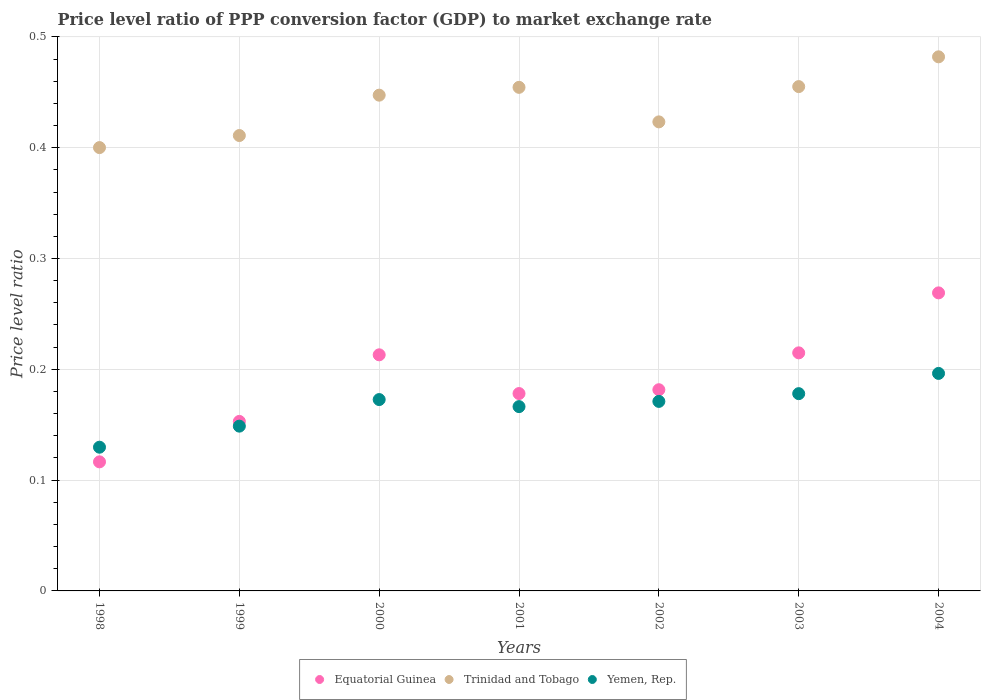How many different coloured dotlines are there?
Offer a terse response. 3. Is the number of dotlines equal to the number of legend labels?
Offer a terse response. Yes. What is the price level ratio in Yemen, Rep. in 2001?
Ensure brevity in your answer.  0.17. Across all years, what is the maximum price level ratio in Trinidad and Tobago?
Make the answer very short. 0.48. Across all years, what is the minimum price level ratio in Equatorial Guinea?
Ensure brevity in your answer.  0.12. What is the total price level ratio in Equatorial Guinea in the graph?
Ensure brevity in your answer.  1.33. What is the difference between the price level ratio in Equatorial Guinea in 2000 and that in 2001?
Your answer should be compact. 0.03. What is the difference between the price level ratio in Yemen, Rep. in 2003 and the price level ratio in Equatorial Guinea in 2000?
Make the answer very short. -0.04. What is the average price level ratio in Equatorial Guinea per year?
Offer a terse response. 0.19. In the year 2000, what is the difference between the price level ratio in Equatorial Guinea and price level ratio in Yemen, Rep.?
Your response must be concise. 0.04. What is the ratio of the price level ratio in Yemen, Rep. in 1999 to that in 2002?
Your answer should be compact. 0.87. Is the price level ratio in Yemen, Rep. in 2002 less than that in 2004?
Make the answer very short. Yes. What is the difference between the highest and the second highest price level ratio in Equatorial Guinea?
Offer a very short reply. 0.05. What is the difference between the highest and the lowest price level ratio in Yemen, Rep.?
Provide a short and direct response. 0.07. Is the sum of the price level ratio in Yemen, Rep. in 2002 and 2003 greater than the maximum price level ratio in Equatorial Guinea across all years?
Offer a terse response. Yes. Is it the case that in every year, the sum of the price level ratio in Equatorial Guinea and price level ratio in Trinidad and Tobago  is greater than the price level ratio in Yemen, Rep.?
Your response must be concise. Yes. Does the price level ratio in Trinidad and Tobago monotonically increase over the years?
Your answer should be very brief. No. Is the price level ratio in Trinidad and Tobago strictly less than the price level ratio in Equatorial Guinea over the years?
Provide a short and direct response. No. How many dotlines are there?
Give a very brief answer. 3. What is the difference between two consecutive major ticks on the Y-axis?
Keep it short and to the point. 0.1. Does the graph contain grids?
Keep it short and to the point. Yes. Where does the legend appear in the graph?
Provide a succinct answer. Bottom center. How many legend labels are there?
Offer a terse response. 3. How are the legend labels stacked?
Give a very brief answer. Horizontal. What is the title of the graph?
Offer a very short reply. Price level ratio of PPP conversion factor (GDP) to market exchange rate. What is the label or title of the Y-axis?
Give a very brief answer. Price level ratio. What is the Price level ratio of Equatorial Guinea in 1998?
Provide a succinct answer. 0.12. What is the Price level ratio of Trinidad and Tobago in 1998?
Offer a very short reply. 0.4. What is the Price level ratio in Yemen, Rep. in 1998?
Make the answer very short. 0.13. What is the Price level ratio in Equatorial Guinea in 1999?
Your answer should be compact. 0.15. What is the Price level ratio of Trinidad and Tobago in 1999?
Offer a terse response. 0.41. What is the Price level ratio in Yemen, Rep. in 1999?
Ensure brevity in your answer.  0.15. What is the Price level ratio in Equatorial Guinea in 2000?
Ensure brevity in your answer.  0.21. What is the Price level ratio in Trinidad and Tobago in 2000?
Your answer should be compact. 0.45. What is the Price level ratio of Yemen, Rep. in 2000?
Ensure brevity in your answer.  0.17. What is the Price level ratio of Equatorial Guinea in 2001?
Give a very brief answer. 0.18. What is the Price level ratio in Trinidad and Tobago in 2001?
Offer a terse response. 0.45. What is the Price level ratio of Yemen, Rep. in 2001?
Give a very brief answer. 0.17. What is the Price level ratio in Equatorial Guinea in 2002?
Keep it short and to the point. 0.18. What is the Price level ratio of Trinidad and Tobago in 2002?
Make the answer very short. 0.42. What is the Price level ratio in Yemen, Rep. in 2002?
Your answer should be compact. 0.17. What is the Price level ratio in Equatorial Guinea in 2003?
Offer a very short reply. 0.21. What is the Price level ratio of Trinidad and Tobago in 2003?
Make the answer very short. 0.46. What is the Price level ratio in Yemen, Rep. in 2003?
Make the answer very short. 0.18. What is the Price level ratio in Equatorial Guinea in 2004?
Keep it short and to the point. 0.27. What is the Price level ratio in Trinidad and Tobago in 2004?
Offer a very short reply. 0.48. What is the Price level ratio in Yemen, Rep. in 2004?
Your response must be concise. 0.2. Across all years, what is the maximum Price level ratio of Equatorial Guinea?
Provide a short and direct response. 0.27. Across all years, what is the maximum Price level ratio in Trinidad and Tobago?
Provide a short and direct response. 0.48. Across all years, what is the maximum Price level ratio in Yemen, Rep.?
Offer a very short reply. 0.2. Across all years, what is the minimum Price level ratio of Equatorial Guinea?
Your answer should be very brief. 0.12. Across all years, what is the minimum Price level ratio of Trinidad and Tobago?
Offer a terse response. 0.4. Across all years, what is the minimum Price level ratio in Yemen, Rep.?
Provide a short and direct response. 0.13. What is the total Price level ratio of Equatorial Guinea in the graph?
Your answer should be compact. 1.33. What is the total Price level ratio in Trinidad and Tobago in the graph?
Provide a succinct answer. 3.07. What is the total Price level ratio in Yemen, Rep. in the graph?
Your answer should be very brief. 1.16. What is the difference between the Price level ratio of Equatorial Guinea in 1998 and that in 1999?
Provide a succinct answer. -0.04. What is the difference between the Price level ratio in Trinidad and Tobago in 1998 and that in 1999?
Your response must be concise. -0.01. What is the difference between the Price level ratio in Yemen, Rep. in 1998 and that in 1999?
Keep it short and to the point. -0.02. What is the difference between the Price level ratio in Equatorial Guinea in 1998 and that in 2000?
Provide a succinct answer. -0.1. What is the difference between the Price level ratio in Trinidad and Tobago in 1998 and that in 2000?
Offer a terse response. -0.05. What is the difference between the Price level ratio of Yemen, Rep. in 1998 and that in 2000?
Keep it short and to the point. -0.04. What is the difference between the Price level ratio of Equatorial Guinea in 1998 and that in 2001?
Ensure brevity in your answer.  -0.06. What is the difference between the Price level ratio of Trinidad and Tobago in 1998 and that in 2001?
Offer a very short reply. -0.05. What is the difference between the Price level ratio of Yemen, Rep. in 1998 and that in 2001?
Your answer should be very brief. -0.04. What is the difference between the Price level ratio of Equatorial Guinea in 1998 and that in 2002?
Your response must be concise. -0.07. What is the difference between the Price level ratio in Trinidad and Tobago in 1998 and that in 2002?
Provide a succinct answer. -0.02. What is the difference between the Price level ratio of Yemen, Rep. in 1998 and that in 2002?
Keep it short and to the point. -0.04. What is the difference between the Price level ratio in Equatorial Guinea in 1998 and that in 2003?
Make the answer very short. -0.1. What is the difference between the Price level ratio in Trinidad and Tobago in 1998 and that in 2003?
Make the answer very short. -0.06. What is the difference between the Price level ratio in Yemen, Rep. in 1998 and that in 2003?
Offer a terse response. -0.05. What is the difference between the Price level ratio in Equatorial Guinea in 1998 and that in 2004?
Give a very brief answer. -0.15. What is the difference between the Price level ratio in Trinidad and Tobago in 1998 and that in 2004?
Your response must be concise. -0.08. What is the difference between the Price level ratio of Yemen, Rep. in 1998 and that in 2004?
Give a very brief answer. -0.07. What is the difference between the Price level ratio of Equatorial Guinea in 1999 and that in 2000?
Make the answer very short. -0.06. What is the difference between the Price level ratio of Trinidad and Tobago in 1999 and that in 2000?
Provide a succinct answer. -0.04. What is the difference between the Price level ratio in Yemen, Rep. in 1999 and that in 2000?
Your answer should be compact. -0.02. What is the difference between the Price level ratio in Equatorial Guinea in 1999 and that in 2001?
Offer a terse response. -0.03. What is the difference between the Price level ratio of Trinidad and Tobago in 1999 and that in 2001?
Keep it short and to the point. -0.04. What is the difference between the Price level ratio of Yemen, Rep. in 1999 and that in 2001?
Offer a terse response. -0.02. What is the difference between the Price level ratio of Equatorial Guinea in 1999 and that in 2002?
Give a very brief answer. -0.03. What is the difference between the Price level ratio of Trinidad and Tobago in 1999 and that in 2002?
Give a very brief answer. -0.01. What is the difference between the Price level ratio in Yemen, Rep. in 1999 and that in 2002?
Your response must be concise. -0.02. What is the difference between the Price level ratio in Equatorial Guinea in 1999 and that in 2003?
Make the answer very short. -0.06. What is the difference between the Price level ratio in Trinidad and Tobago in 1999 and that in 2003?
Keep it short and to the point. -0.04. What is the difference between the Price level ratio of Yemen, Rep. in 1999 and that in 2003?
Offer a very short reply. -0.03. What is the difference between the Price level ratio in Equatorial Guinea in 1999 and that in 2004?
Ensure brevity in your answer.  -0.12. What is the difference between the Price level ratio of Trinidad and Tobago in 1999 and that in 2004?
Provide a short and direct response. -0.07. What is the difference between the Price level ratio of Yemen, Rep. in 1999 and that in 2004?
Your answer should be very brief. -0.05. What is the difference between the Price level ratio in Equatorial Guinea in 2000 and that in 2001?
Offer a very short reply. 0.04. What is the difference between the Price level ratio in Trinidad and Tobago in 2000 and that in 2001?
Make the answer very short. -0.01. What is the difference between the Price level ratio in Yemen, Rep. in 2000 and that in 2001?
Offer a very short reply. 0.01. What is the difference between the Price level ratio of Equatorial Guinea in 2000 and that in 2002?
Offer a terse response. 0.03. What is the difference between the Price level ratio of Trinidad and Tobago in 2000 and that in 2002?
Make the answer very short. 0.02. What is the difference between the Price level ratio of Yemen, Rep. in 2000 and that in 2002?
Your response must be concise. 0. What is the difference between the Price level ratio in Equatorial Guinea in 2000 and that in 2003?
Provide a succinct answer. -0. What is the difference between the Price level ratio of Trinidad and Tobago in 2000 and that in 2003?
Provide a succinct answer. -0.01. What is the difference between the Price level ratio in Yemen, Rep. in 2000 and that in 2003?
Your response must be concise. -0.01. What is the difference between the Price level ratio in Equatorial Guinea in 2000 and that in 2004?
Provide a succinct answer. -0.06. What is the difference between the Price level ratio of Trinidad and Tobago in 2000 and that in 2004?
Provide a succinct answer. -0.03. What is the difference between the Price level ratio in Yemen, Rep. in 2000 and that in 2004?
Your answer should be very brief. -0.02. What is the difference between the Price level ratio of Equatorial Guinea in 2001 and that in 2002?
Ensure brevity in your answer.  -0. What is the difference between the Price level ratio in Trinidad and Tobago in 2001 and that in 2002?
Keep it short and to the point. 0.03. What is the difference between the Price level ratio of Yemen, Rep. in 2001 and that in 2002?
Provide a succinct answer. -0. What is the difference between the Price level ratio of Equatorial Guinea in 2001 and that in 2003?
Ensure brevity in your answer.  -0.04. What is the difference between the Price level ratio of Trinidad and Tobago in 2001 and that in 2003?
Provide a succinct answer. -0. What is the difference between the Price level ratio of Yemen, Rep. in 2001 and that in 2003?
Your answer should be compact. -0.01. What is the difference between the Price level ratio in Equatorial Guinea in 2001 and that in 2004?
Offer a very short reply. -0.09. What is the difference between the Price level ratio of Trinidad and Tobago in 2001 and that in 2004?
Give a very brief answer. -0.03. What is the difference between the Price level ratio of Yemen, Rep. in 2001 and that in 2004?
Keep it short and to the point. -0.03. What is the difference between the Price level ratio in Equatorial Guinea in 2002 and that in 2003?
Make the answer very short. -0.03. What is the difference between the Price level ratio of Trinidad and Tobago in 2002 and that in 2003?
Your response must be concise. -0.03. What is the difference between the Price level ratio of Yemen, Rep. in 2002 and that in 2003?
Provide a succinct answer. -0.01. What is the difference between the Price level ratio of Equatorial Guinea in 2002 and that in 2004?
Your answer should be very brief. -0.09. What is the difference between the Price level ratio of Trinidad and Tobago in 2002 and that in 2004?
Offer a terse response. -0.06. What is the difference between the Price level ratio in Yemen, Rep. in 2002 and that in 2004?
Give a very brief answer. -0.03. What is the difference between the Price level ratio of Equatorial Guinea in 2003 and that in 2004?
Your answer should be compact. -0.05. What is the difference between the Price level ratio of Trinidad and Tobago in 2003 and that in 2004?
Give a very brief answer. -0.03. What is the difference between the Price level ratio of Yemen, Rep. in 2003 and that in 2004?
Your answer should be very brief. -0.02. What is the difference between the Price level ratio of Equatorial Guinea in 1998 and the Price level ratio of Trinidad and Tobago in 1999?
Make the answer very short. -0.29. What is the difference between the Price level ratio of Equatorial Guinea in 1998 and the Price level ratio of Yemen, Rep. in 1999?
Ensure brevity in your answer.  -0.03. What is the difference between the Price level ratio of Trinidad and Tobago in 1998 and the Price level ratio of Yemen, Rep. in 1999?
Provide a short and direct response. 0.25. What is the difference between the Price level ratio in Equatorial Guinea in 1998 and the Price level ratio in Trinidad and Tobago in 2000?
Your response must be concise. -0.33. What is the difference between the Price level ratio of Equatorial Guinea in 1998 and the Price level ratio of Yemen, Rep. in 2000?
Provide a short and direct response. -0.06. What is the difference between the Price level ratio in Trinidad and Tobago in 1998 and the Price level ratio in Yemen, Rep. in 2000?
Provide a short and direct response. 0.23. What is the difference between the Price level ratio in Equatorial Guinea in 1998 and the Price level ratio in Trinidad and Tobago in 2001?
Keep it short and to the point. -0.34. What is the difference between the Price level ratio of Equatorial Guinea in 1998 and the Price level ratio of Yemen, Rep. in 2001?
Provide a short and direct response. -0.05. What is the difference between the Price level ratio in Trinidad and Tobago in 1998 and the Price level ratio in Yemen, Rep. in 2001?
Make the answer very short. 0.23. What is the difference between the Price level ratio of Equatorial Guinea in 1998 and the Price level ratio of Trinidad and Tobago in 2002?
Your answer should be very brief. -0.31. What is the difference between the Price level ratio of Equatorial Guinea in 1998 and the Price level ratio of Yemen, Rep. in 2002?
Your answer should be very brief. -0.05. What is the difference between the Price level ratio of Trinidad and Tobago in 1998 and the Price level ratio of Yemen, Rep. in 2002?
Offer a very short reply. 0.23. What is the difference between the Price level ratio of Equatorial Guinea in 1998 and the Price level ratio of Trinidad and Tobago in 2003?
Your answer should be compact. -0.34. What is the difference between the Price level ratio of Equatorial Guinea in 1998 and the Price level ratio of Yemen, Rep. in 2003?
Your answer should be compact. -0.06. What is the difference between the Price level ratio in Trinidad and Tobago in 1998 and the Price level ratio in Yemen, Rep. in 2003?
Provide a short and direct response. 0.22. What is the difference between the Price level ratio in Equatorial Guinea in 1998 and the Price level ratio in Trinidad and Tobago in 2004?
Give a very brief answer. -0.37. What is the difference between the Price level ratio of Equatorial Guinea in 1998 and the Price level ratio of Yemen, Rep. in 2004?
Ensure brevity in your answer.  -0.08. What is the difference between the Price level ratio in Trinidad and Tobago in 1998 and the Price level ratio in Yemen, Rep. in 2004?
Offer a very short reply. 0.2. What is the difference between the Price level ratio of Equatorial Guinea in 1999 and the Price level ratio of Trinidad and Tobago in 2000?
Provide a succinct answer. -0.29. What is the difference between the Price level ratio of Equatorial Guinea in 1999 and the Price level ratio of Yemen, Rep. in 2000?
Your response must be concise. -0.02. What is the difference between the Price level ratio of Trinidad and Tobago in 1999 and the Price level ratio of Yemen, Rep. in 2000?
Your answer should be compact. 0.24. What is the difference between the Price level ratio of Equatorial Guinea in 1999 and the Price level ratio of Trinidad and Tobago in 2001?
Ensure brevity in your answer.  -0.3. What is the difference between the Price level ratio of Equatorial Guinea in 1999 and the Price level ratio of Yemen, Rep. in 2001?
Give a very brief answer. -0.01. What is the difference between the Price level ratio in Trinidad and Tobago in 1999 and the Price level ratio in Yemen, Rep. in 2001?
Provide a succinct answer. 0.24. What is the difference between the Price level ratio in Equatorial Guinea in 1999 and the Price level ratio in Trinidad and Tobago in 2002?
Your response must be concise. -0.27. What is the difference between the Price level ratio in Equatorial Guinea in 1999 and the Price level ratio in Yemen, Rep. in 2002?
Your answer should be compact. -0.02. What is the difference between the Price level ratio of Trinidad and Tobago in 1999 and the Price level ratio of Yemen, Rep. in 2002?
Provide a short and direct response. 0.24. What is the difference between the Price level ratio in Equatorial Guinea in 1999 and the Price level ratio in Trinidad and Tobago in 2003?
Provide a succinct answer. -0.3. What is the difference between the Price level ratio in Equatorial Guinea in 1999 and the Price level ratio in Yemen, Rep. in 2003?
Keep it short and to the point. -0.03. What is the difference between the Price level ratio of Trinidad and Tobago in 1999 and the Price level ratio of Yemen, Rep. in 2003?
Your answer should be compact. 0.23. What is the difference between the Price level ratio of Equatorial Guinea in 1999 and the Price level ratio of Trinidad and Tobago in 2004?
Your answer should be compact. -0.33. What is the difference between the Price level ratio in Equatorial Guinea in 1999 and the Price level ratio in Yemen, Rep. in 2004?
Your answer should be compact. -0.04. What is the difference between the Price level ratio of Trinidad and Tobago in 1999 and the Price level ratio of Yemen, Rep. in 2004?
Provide a short and direct response. 0.21. What is the difference between the Price level ratio in Equatorial Guinea in 2000 and the Price level ratio in Trinidad and Tobago in 2001?
Your answer should be very brief. -0.24. What is the difference between the Price level ratio in Equatorial Guinea in 2000 and the Price level ratio in Yemen, Rep. in 2001?
Keep it short and to the point. 0.05. What is the difference between the Price level ratio in Trinidad and Tobago in 2000 and the Price level ratio in Yemen, Rep. in 2001?
Provide a succinct answer. 0.28. What is the difference between the Price level ratio in Equatorial Guinea in 2000 and the Price level ratio in Trinidad and Tobago in 2002?
Offer a terse response. -0.21. What is the difference between the Price level ratio in Equatorial Guinea in 2000 and the Price level ratio in Yemen, Rep. in 2002?
Your response must be concise. 0.04. What is the difference between the Price level ratio in Trinidad and Tobago in 2000 and the Price level ratio in Yemen, Rep. in 2002?
Provide a succinct answer. 0.28. What is the difference between the Price level ratio in Equatorial Guinea in 2000 and the Price level ratio in Trinidad and Tobago in 2003?
Provide a short and direct response. -0.24. What is the difference between the Price level ratio in Equatorial Guinea in 2000 and the Price level ratio in Yemen, Rep. in 2003?
Your response must be concise. 0.04. What is the difference between the Price level ratio of Trinidad and Tobago in 2000 and the Price level ratio of Yemen, Rep. in 2003?
Offer a very short reply. 0.27. What is the difference between the Price level ratio of Equatorial Guinea in 2000 and the Price level ratio of Trinidad and Tobago in 2004?
Your response must be concise. -0.27. What is the difference between the Price level ratio of Equatorial Guinea in 2000 and the Price level ratio of Yemen, Rep. in 2004?
Offer a terse response. 0.02. What is the difference between the Price level ratio in Trinidad and Tobago in 2000 and the Price level ratio in Yemen, Rep. in 2004?
Make the answer very short. 0.25. What is the difference between the Price level ratio in Equatorial Guinea in 2001 and the Price level ratio in Trinidad and Tobago in 2002?
Give a very brief answer. -0.25. What is the difference between the Price level ratio of Equatorial Guinea in 2001 and the Price level ratio of Yemen, Rep. in 2002?
Provide a succinct answer. 0.01. What is the difference between the Price level ratio in Trinidad and Tobago in 2001 and the Price level ratio in Yemen, Rep. in 2002?
Offer a very short reply. 0.28. What is the difference between the Price level ratio in Equatorial Guinea in 2001 and the Price level ratio in Trinidad and Tobago in 2003?
Your response must be concise. -0.28. What is the difference between the Price level ratio in Equatorial Guinea in 2001 and the Price level ratio in Yemen, Rep. in 2003?
Provide a short and direct response. 0. What is the difference between the Price level ratio in Trinidad and Tobago in 2001 and the Price level ratio in Yemen, Rep. in 2003?
Make the answer very short. 0.28. What is the difference between the Price level ratio in Equatorial Guinea in 2001 and the Price level ratio in Trinidad and Tobago in 2004?
Your answer should be compact. -0.3. What is the difference between the Price level ratio of Equatorial Guinea in 2001 and the Price level ratio of Yemen, Rep. in 2004?
Give a very brief answer. -0.02. What is the difference between the Price level ratio of Trinidad and Tobago in 2001 and the Price level ratio of Yemen, Rep. in 2004?
Offer a very short reply. 0.26. What is the difference between the Price level ratio in Equatorial Guinea in 2002 and the Price level ratio in Trinidad and Tobago in 2003?
Keep it short and to the point. -0.27. What is the difference between the Price level ratio in Equatorial Guinea in 2002 and the Price level ratio in Yemen, Rep. in 2003?
Your answer should be very brief. 0. What is the difference between the Price level ratio of Trinidad and Tobago in 2002 and the Price level ratio of Yemen, Rep. in 2003?
Offer a terse response. 0.25. What is the difference between the Price level ratio of Equatorial Guinea in 2002 and the Price level ratio of Trinidad and Tobago in 2004?
Make the answer very short. -0.3. What is the difference between the Price level ratio in Equatorial Guinea in 2002 and the Price level ratio in Yemen, Rep. in 2004?
Give a very brief answer. -0.01. What is the difference between the Price level ratio in Trinidad and Tobago in 2002 and the Price level ratio in Yemen, Rep. in 2004?
Offer a very short reply. 0.23. What is the difference between the Price level ratio in Equatorial Guinea in 2003 and the Price level ratio in Trinidad and Tobago in 2004?
Keep it short and to the point. -0.27. What is the difference between the Price level ratio in Equatorial Guinea in 2003 and the Price level ratio in Yemen, Rep. in 2004?
Make the answer very short. 0.02. What is the difference between the Price level ratio in Trinidad and Tobago in 2003 and the Price level ratio in Yemen, Rep. in 2004?
Keep it short and to the point. 0.26. What is the average Price level ratio of Equatorial Guinea per year?
Provide a succinct answer. 0.19. What is the average Price level ratio in Trinidad and Tobago per year?
Your answer should be very brief. 0.44. What is the average Price level ratio in Yemen, Rep. per year?
Ensure brevity in your answer.  0.17. In the year 1998, what is the difference between the Price level ratio of Equatorial Guinea and Price level ratio of Trinidad and Tobago?
Your answer should be very brief. -0.28. In the year 1998, what is the difference between the Price level ratio in Equatorial Guinea and Price level ratio in Yemen, Rep.?
Give a very brief answer. -0.01. In the year 1998, what is the difference between the Price level ratio of Trinidad and Tobago and Price level ratio of Yemen, Rep.?
Provide a short and direct response. 0.27. In the year 1999, what is the difference between the Price level ratio in Equatorial Guinea and Price level ratio in Trinidad and Tobago?
Offer a very short reply. -0.26. In the year 1999, what is the difference between the Price level ratio of Equatorial Guinea and Price level ratio of Yemen, Rep.?
Provide a succinct answer. 0. In the year 1999, what is the difference between the Price level ratio of Trinidad and Tobago and Price level ratio of Yemen, Rep.?
Keep it short and to the point. 0.26. In the year 2000, what is the difference between the Price level ratio of Equatorial Guinea and Price level ratio of Trinidad and Tobago?
Ensure brevity in your answer.  -0.23. In the year 2000, what is the difference between the Price level ratio of Equatorial Guinea and Price level ratio of Yemen, Rep.?
Your answer should be very brief. 0.04. In the year 2000, what is the difference between the Price level ratio in Trinidad and Tobago and Price level ratio in Yemen, Rep.?
Your answer should be compact. 0.27. In the year 2001, what is the difference between the Price level ratio of Equatorial Guinea and Price level ratio of Trinidad and Tobago?
Provide a short and direct response. -0.28. In the year 2001, what is the difference between the Price level ratio in Equatorial Guinea and Price level ratio in Yemen, Rep.?
Provide a succinct answer. 0.01. In the year 2001, what is the difference between the Price level ratio in Trinidad and Tobago and Price level ratio in Yemen, Rep.?
Your answer should be compact. 0.29. In the year 2002, what is the difference between the Price level ratio in Equatorial Guinea and Price level ratio in Trinidad and Tobago?
Ensure brevity in your answer.  -0.24. In the year 2002, what is the difference between the Price level ratio in Equatorial Guinea and Price level ratio in Yemen, Rep.?
Give a very brief answer. 0.01. In the year 2002, what is the difference between the Price level ratio in Trinidad and Tobago and Price level ratio in Yemen, Rep.?
Make the answer very short. 0.25. In the year 2003, what is the difference between the Price level ratio of Equatorial Guinea and Price level ratio of Trinidad and Tobago?
Ensure brevity in your answer.  -0.24. In the year 2003, what is the difference between the Price level ratio of Equatorial Guinea and Price level ratio of Yemen, Rep.?
Make the answer very short. 0.04. In the year 2003, what is the difference between the Price level ratio in Trinidad and Tobago and Price level ratio in Yemen, Rep.?
Provide a succinct answer. 0.28. In the year 2004, what is the difference between the Price level ratio of Equatorial Guinea and Price level ratio of Trinidad and Tobago?
Make the answer very short. -0.21. In the year 2004, what is the difference between the Price level ratio of Equatorial Guinea and Price level ratio of Yemen, Rep.?
Your answer should be very brief. 0.07. In the year 2004, what is the difference between the Price level ratio in Trinidad and Tobago and Price level ratio in Yemen, Rep.?
Give a very brief answer. 0.29. What is the ratio of the Price level ratio in Equatorial Guinea in 1998 to that in 1999?
Make the answer very short. 0.76. What is the ratio of the Price level ratio of Trinidad and Tobago in 1998 to that in 1999?
Your answer should be compact. 0.97. What is the ratio of the Price level ratio of Yemen, Rep. in 1998 to that in 1999?
Your answer should be compact. 0.87. What is the ratio of the Price level ratio in Equatorial Guinea in 1998 to that in 2000?
Your response must be concise. 0.55. What is the ratio of the Price level ratio in Trinidad and Tobago in 1998 to that in 2000?
Offer a very short reply. 0.89. What is the ratio of the Price level ratio of Yemen, Rep. in 1998 to that in 2000?
Provide a short and direct response. 0.75. What is the ratio of the Price level ratio in Equatorial Guinea in 1998 to that in 2001?
Make the answer very short. 0.65. What is the ratio of the Price level ratio in Trinidad and Tobago in 1998 to that in 2001?
Your answer should be compact. 0.88. What is the ratio of the Price level ratio of Yemen, Rep. in 1998 to that in 2001?
Your answer should be compact. 0.78. What is the ratio of the Price level ratio of Equatorial Guinea in 1998 to that in 2002?
Make the answer very short. 0.64. What is the ratio of the Price level ratio in Trinidad and Tobago in 1998 to that in 2002?
Your answer should be very brief. 0.95. What is the ratio of the Price level ratio of Yemen, Rep. in 1998 to that in 2002?
Your answer should be very brief. 0.76. What is the ratio of the Price level ratio of Equatorial Guinea in 1998 to that in 2003?
Your response must be concise. 0.54. What is the ratio of the Price level ratio in Trinidad and Tobago in 1998 to that in 2003?
Ensure brevity in your answer.  0.88. What is the ratio of the Price level ratio in Yemen, Rep. in 1998 to that in 2003?
Provide a short and direct response. 0.73. What is the ratio of the Price level ratio of Equatorial Guinea in 1998 to that in 2004?
Your response must be concise. 0.43. What is the ratio of the Price level ratio of Trinidad and Tobago in 1998 to that in 2004?
Ensure brevity in your answer.  0.83. What is the ratio of the Price level ratio of Yemen, Rep. in 1998 to that in 2004?
Make the answer very short. 0.66. What is the ratio of the Price level ratio of Equatorial Guinea in 1999 to that in 2000?
Your response must be concise. 0.72. What is the ratio of the Price level ratio of Trinidad and Tobago in 1999 to that in 2000?
Ensure brevity in your answer.  0.92. What is the ratio of the Price level ratio in Yemen, Rep. in 1999 to that in 2000?
Your answer should be compact. 0.86. What is the ratio of the Price level ratio of Equatorial Guinea in 1999 to that in 2001?
Make the answer very short. 0.86. What is the ratio of the Price level ratio in Trinidad and Tobago in 1999 to that in 2001?
Ensure brevity in your answer.  0.9. What is the ratio of the Price level ratio in Yemen, Rep. in 1999 to that in 2001?
Offer a very short reply. 0.89. What is the ratio of the Price level ratio of Equatorial Guinea in 1999 to that in 2002?
Provide a succinct answer. 0.84. What is the ratio of the Price level ratio in Trinidad and Tobago in 1999 to that in 2002?
Your response must be concise. 0.97. What is the ratio of the Price level ratio in Yemen, Rep. in 1999 to that in 2002?
Your answer should be compact. 0.87. What is the ratio of the Price level ratio of Equatorial Guinea in 1999 to that in 2003?
Provide a succinct answer. 0.71. What is the ratio of the Price level ratio in Trinidad and Tobago in 1999 to that in 2003?
Your answer should be compact. 0.9. What is the ratio of the Price level ratio of Yemen, Rep. in 1999 to that in 2003?
Offer a terse response. 0.84. What is the ratio of the Price level ratio of Equatorial Guinea in 1999 to that in 2004?
Offer a very short reply. 0.57. What is the ratio of the Price level ratio of Trinidad and Tobago in 1999 to that in 2004?
Your answer should be compact. 0.85. What is the ratio of the Price level ratio of Yemen, Rep. in 1999 to that in 2004?
Make the answer very short. 0.76. What is the ratio of the Price level ratio in Equatorial Guinea in 2000 to that in 2001?
Provide a succinct answer. 1.2. What is the ratio of the Price level ratio of Trinidad and Tobago in 2000 to that in 2001?
Ensure brevity in your answer.  0.98. What is the ratio of the Price level ratio of Yemen, Rep. in 2000 to that in 2001?
Keep it short and to the point. 1.04. What is the ratio of the Price level ratio in Equatorial Guinea in 2000 to that in 2002?
Your answer should be compact. 1.17. What is the ratio of the Price level ratio in Trinidad and Tobago in 2000 to that in 2002?
Offer a very short reply. 1.06. What is the ratio of the Price level ratio of Yemen, Rep. in 2000 to that in 2002?
Keep it short and to the point. 1.01. What is the ratio of the Price level ratio of Equatorial Guinea in 2000 to that in 2003?
Offer a very short reply. 0.99. What is the ratio of the Price level ratio of Yemen, Rep. in 2000 to that in 2003?
Offer a terse response. 0.97. What is the ratio of the Price level ratio in Equatorial Guinea in 2000 to that in 2004?
Your answer should be compact. 0.79. What is the ratio of the Price level ratio in Trinidad and Tobago in 2000 to that in 2004?
Offer a terse response. 0.93. What is the ratio of the Price level ratio of Yemen, Rep. in 2000 to that in 2004?
Ensure brevity in your answer.  0.88. What is the ratio of the Price level ratio in Equatorial Guinea in 2001 to that in 2002?
Make the answer very short. 0.98. What is the ratio of the Price level ratio of Trinidad and Tobago in 2001 to that in 2002?
Offer a very short reply. 1.07. What is the ratio of the Price level ratio in Yemen, Rep. in 2001 to that in 2002?
Provide a short and direct response. 0.97. What is the ratio of the Price level ratio in Equatorial Guinea in 2001 to that in 2003?
Provide a succinct answer. 0.83. What is the ratio of the Price level ratio in Trinidad and Tobago in 2001 to that in 2003?
Your response must be concise. 1. What is the ratio of the Price level ratio of Yemen, Rep. in 2001 to that in 2003?
Your response must be concise. 0.93. What is the ratio of the Price level ratio of Equatorial Guinea in 2001 to that in 2004?
Give a very brief answer. 0.66. What is the ratio of the Price level ratio of Trinidad and Tobago in 2001 to that in 2004?
Make the answer very short. 0.94. What is the ratio of the Price level ratio of Yemen, Rep. in 2001 to that in 2004?
Provide a succinct answer. 0.85. What is the ratio of the Price level ratio of Equatorial Guinea in 2002 to that in 2003?
Offer a terse response. 0.85. What is the ratio of the Price level ratio of Trinidad and Tobago in 2002 to that in 2003?
Provide a succinct answer. 0.93. What is the ratio of the Price level ratio of Yemen, Rep. in 2002 to that in 2003?
Your answer should be very brief. 0.96. What is the ratio of the Price level ratio of Equatorial Guinea in 2002 to that in 2004?
Your answer should be very brief. 0.68. What is the ratio of the Price level ratio in Trinidad and Tobago in 2002 to that in 2004?
Offer a terse response. 0.88. What is the ratio of the Price level ratio in Yemen, Rep. in 2002 to that in 2004?
Offer a terse response. 0.87. What is the ratio of the Price level ratio of Equatorial Guinea in 2003 to that in 2004?
Offer a very short reply. 0.8. What is the ratio of the Price level ratio in Trinidad and Tobago in 2003 to that in 2004?
Give a very brief answer. 0.94. What is the ratio of the Price level ratio of Yemen, Rep. in 2003 to that in 2004?
Offer a terse response. 0.91. What is the difference between the highest and the second highest Price level ratio in Equatorial Guinea?
Offer a terse response. 0.05. What is the difference between the highest and the second highest Price level ratio of Trinidad and Tobago?
Provide a short and direct response. 0.03. What is the difference between the highest and the second highest Price level ratio of Yemen, Rep.?
Your answer should be compact. 0.02. What is the difference between the highest and the lowest Price level ratio of Equatorial Guinea?
Offer a very short reply. 0.15. What is the difference between the highest and the lowest Price level ratio of Trinidad and Tobago?
Provide a succinct answer. 0.08. What is the difference between the highest and the lowest Price level ratio of Yemen, Rep.?
Keep it short and to the point. 0.07. 